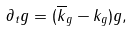Convert formula to latex. <formula><loc_0><loc_0><loc_500><loc_500>\partial _ { t } g = ( \overline { k } _ { g } - k _ { g } ) g ,</formula> 